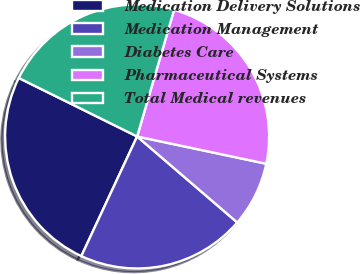Convert chart. <chart><loc_0><loc_0><loc_500><loc_500><pie_chart><fcel>Medication Delivery Solutions<fcel>Medication Management<fcel>Diabetes Care<fcel>Pharmaceutical Systems<fcel>Total Medical revenues<nl><fcel>25.36%<fcel>20.65%<fcel>7.98%<fcel>23.79%<fcel>22.22%<nl></chart> 